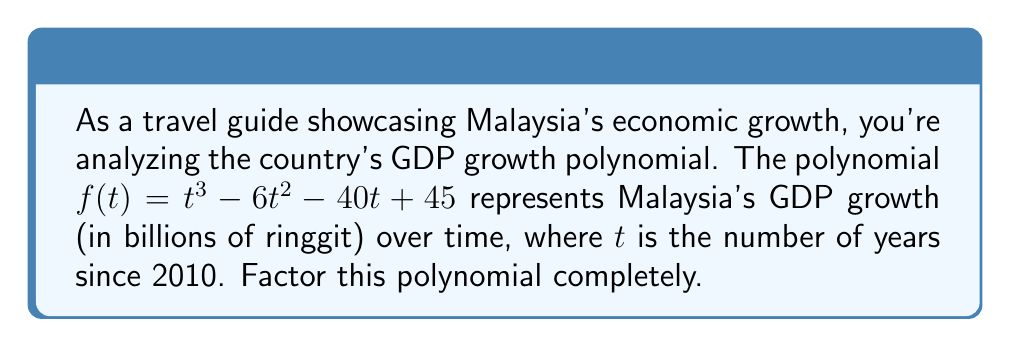Can you solve this math problem? To factor this polynomial, we'll follow these steps:

1) First, let's check if there are any rational roots using the rational root theorem. The possible rational roots are the factors of the constant term: $\pm 1, \pm 3, \pm 5, \pm 9, \pm 15, \pm 45$

2) Testing these values, we find that $t = 5$ is a root. So $(t - 5)$ is a factor.

3) We can use polynomial long division to divide $f(t)$ by $(t - 5)$:

   $$t^3 - 6t^2 - 40t + 45 = (t - 5)(t^2 + 5t - 9)$$

4) Now we need to factor the quadratic $t^2 + 5t - 9$. We can do this by finding two numbers that multiply to give $-9$ and add to give $5$. These numbers are $9$ and $-4$.

5) So we can factor $t^2 + 5t - 9$ as $(t + 9)(t - 4)$

Therefore, the complete factorization is:

$$f(t) = (t - 5)(t + 9)(t - 4)$$

This factorization shows that the GDP growth rate has been zero (crossed the time axis) three times: 5 years after 2010 (in 2015), 4 years before 2010 (in 2006), and 9 years before 2010 (in 2001).
Answer: $f(t) = (t - 5)(t + 9)(t - 4)$ 